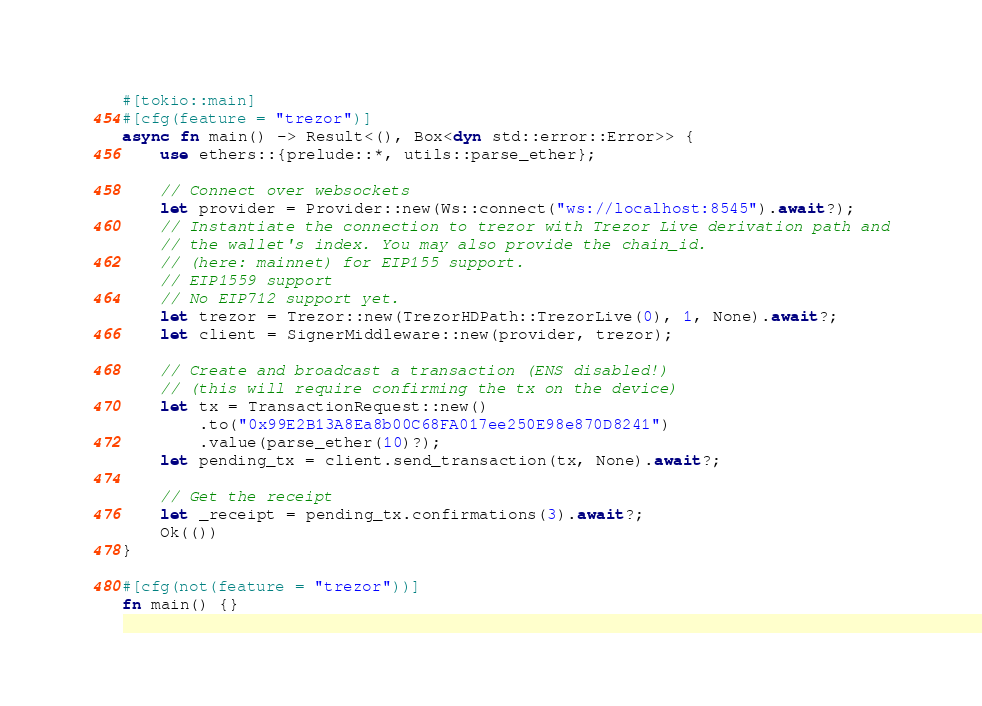Convert code to text. <code><loc_0><loc_0><loc_500><loc_500><_Rust_>#[tokio::main]
#[cfg(feature = "trezor")]
async fn main() -> Result<(), Box<dyn std::error::Error>> {
    use ethers::{prelude::*, utils::parse_ether};

    // Connect over websockets
    let provider = Provider::new(Ws::connect("ws://localhost:8545").await?);
    // Instantiate the connection to trezor with Trezor Live derivation path and
    // the wallet's index. You may also provide the chain_id.
    // (here: mainnet) for EIP155 support.
    // EIP1559 support
    // No EIP712 support yet.
    let trezor = Trezor::new(TrezorHDPath::TrezorLive(0), 1, None).await?;
    let client = SignerMiddleware::new(provider, trezor);

    // Create and broadcast a transaction (ENS disabled!)
    // (this will require confirming the tx on the device)
    let tx = TransactionRequest::new()
        .to("0x99E2B13A8Ea8b00C68FA017ee250E98e870D8241")
        .value(parse_ether(10)?);
    let pending_tx = client.send_transaction(tx, None).await?;

    // Get the receipt
    let _receipt = pending_tx.confirmations(3).await?;
    Ok(())
}

#[cfg(not(feature = "trezor"))]
fn main() {}
</code> 